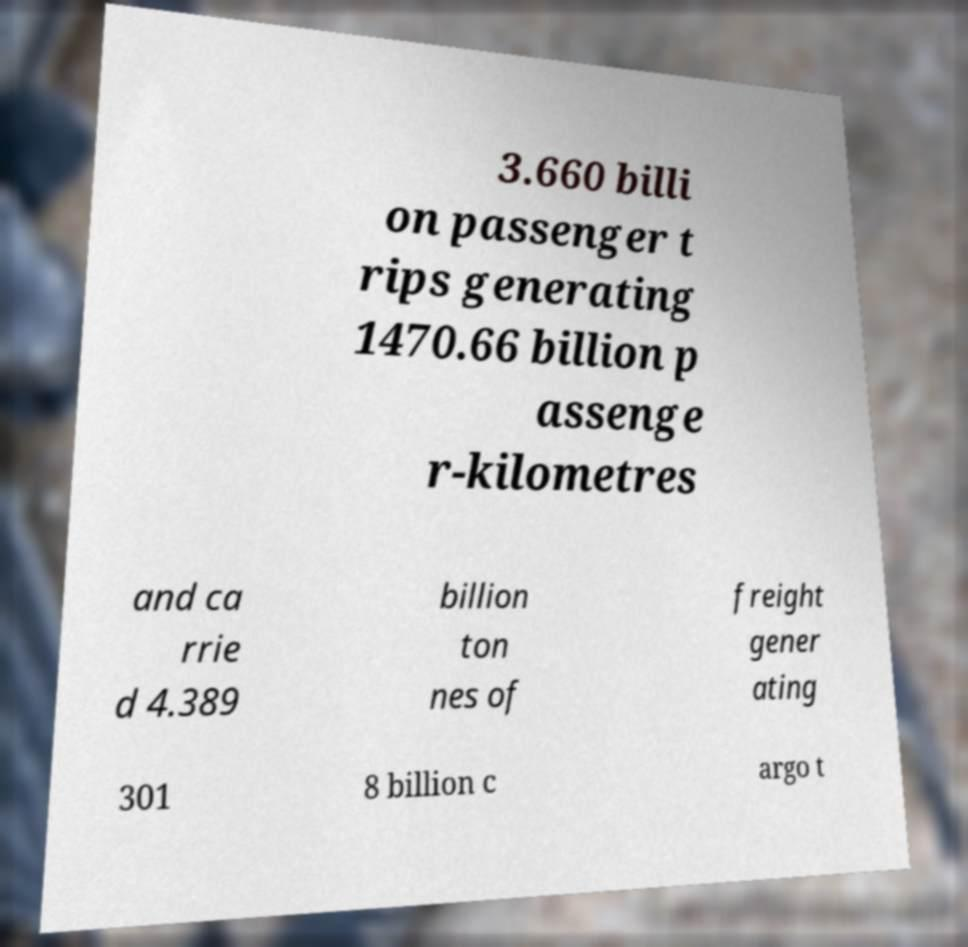Can you read and provide the text displayed in the image?This photo seems to have some interesting text. Can you extract and type it out for me? 3.660 billi on passenger t rips generating 1470.66 billion p assenge r-kilometres and ca rrie d 4.389 billion ton nes of freight gener ating 301 8 billion c argo t 